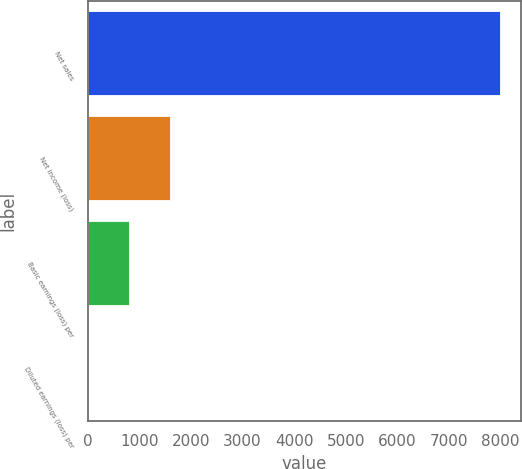Convert chart to OTSL. <chart><loc_0><loc_0><loc_500><loc_500><bar_chart><fcel>Net sales<fcel>Net income (loss)<fcel>Basic earnings (loss) per<fcel>Diluted earnings (loss) per<nl><fcel>7994<fcel>1600.49<fcel>801.3<fcel>2.11<nl></chart> 